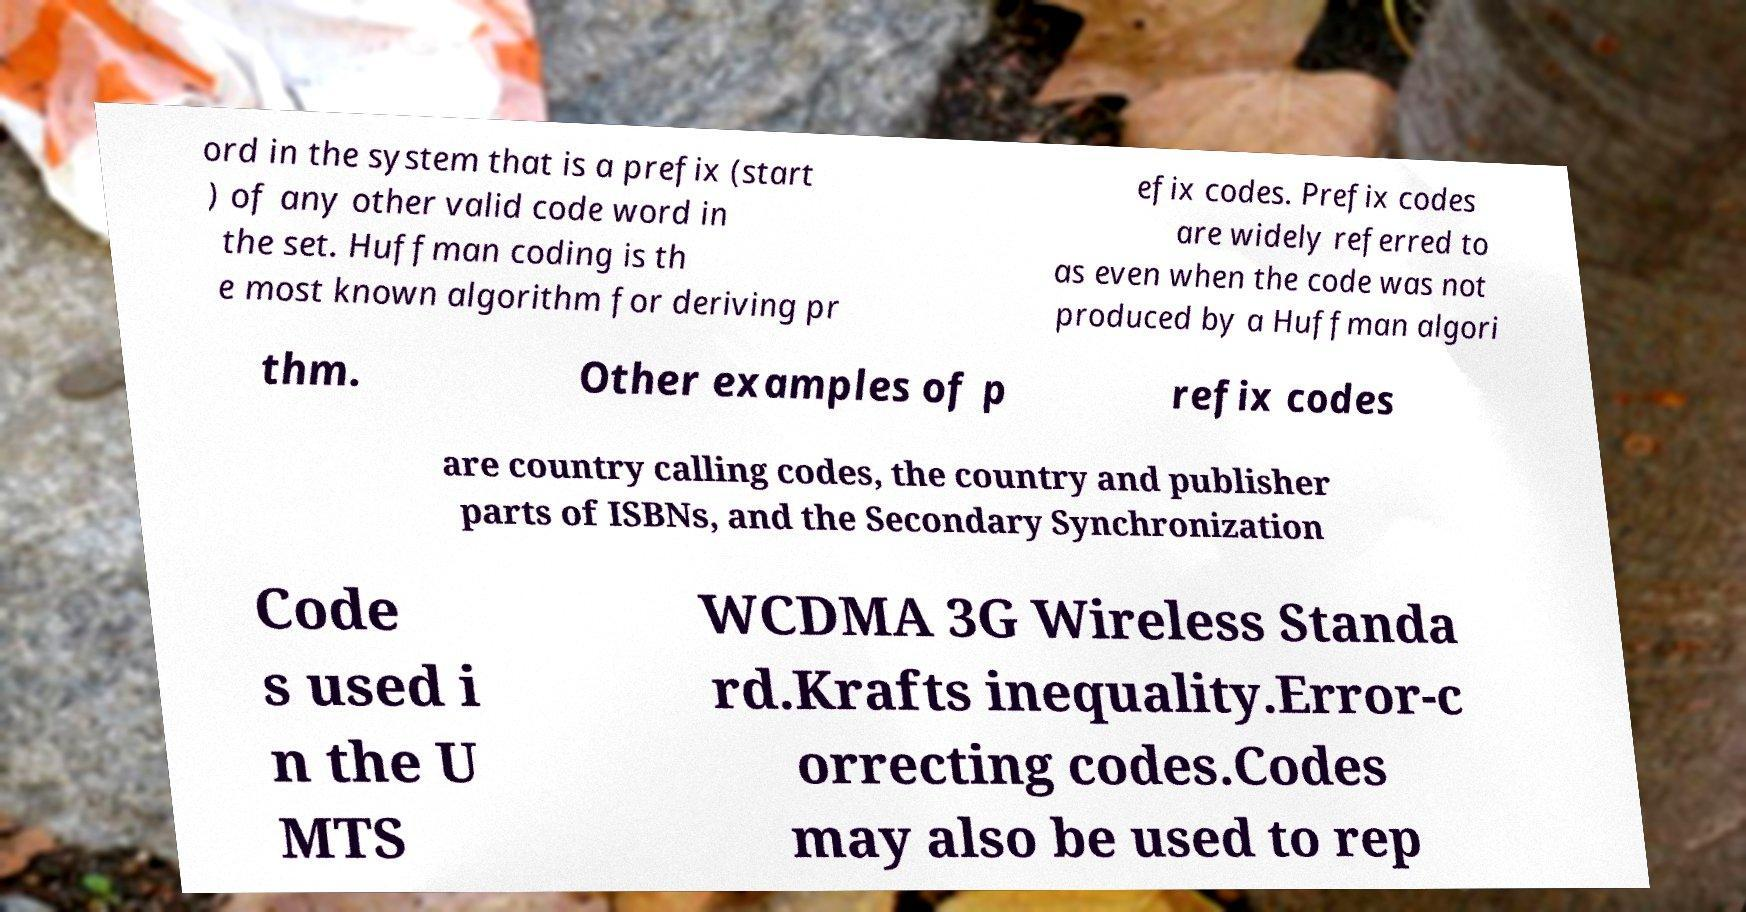For documentation purposes, I need the text within this image transcribed. Could you provide that? ord in the system that is a prefix (start ) of any other valid code word in the set. Huffman coding is th e most known algorithm for deriving pr efix codes. Prefix codes are widely referred to as even when the code was not produced by a Huffman algori thm. Other examples of p refix codes are country calling codes, the country and publisher parts of ISBNs, and the Secondary Synchronization Code s used i n the U MTS WCDMA 3G Wireless Standa rd.Krafts inequality.Error-c orrecting codes.Codes may also be used to rep 